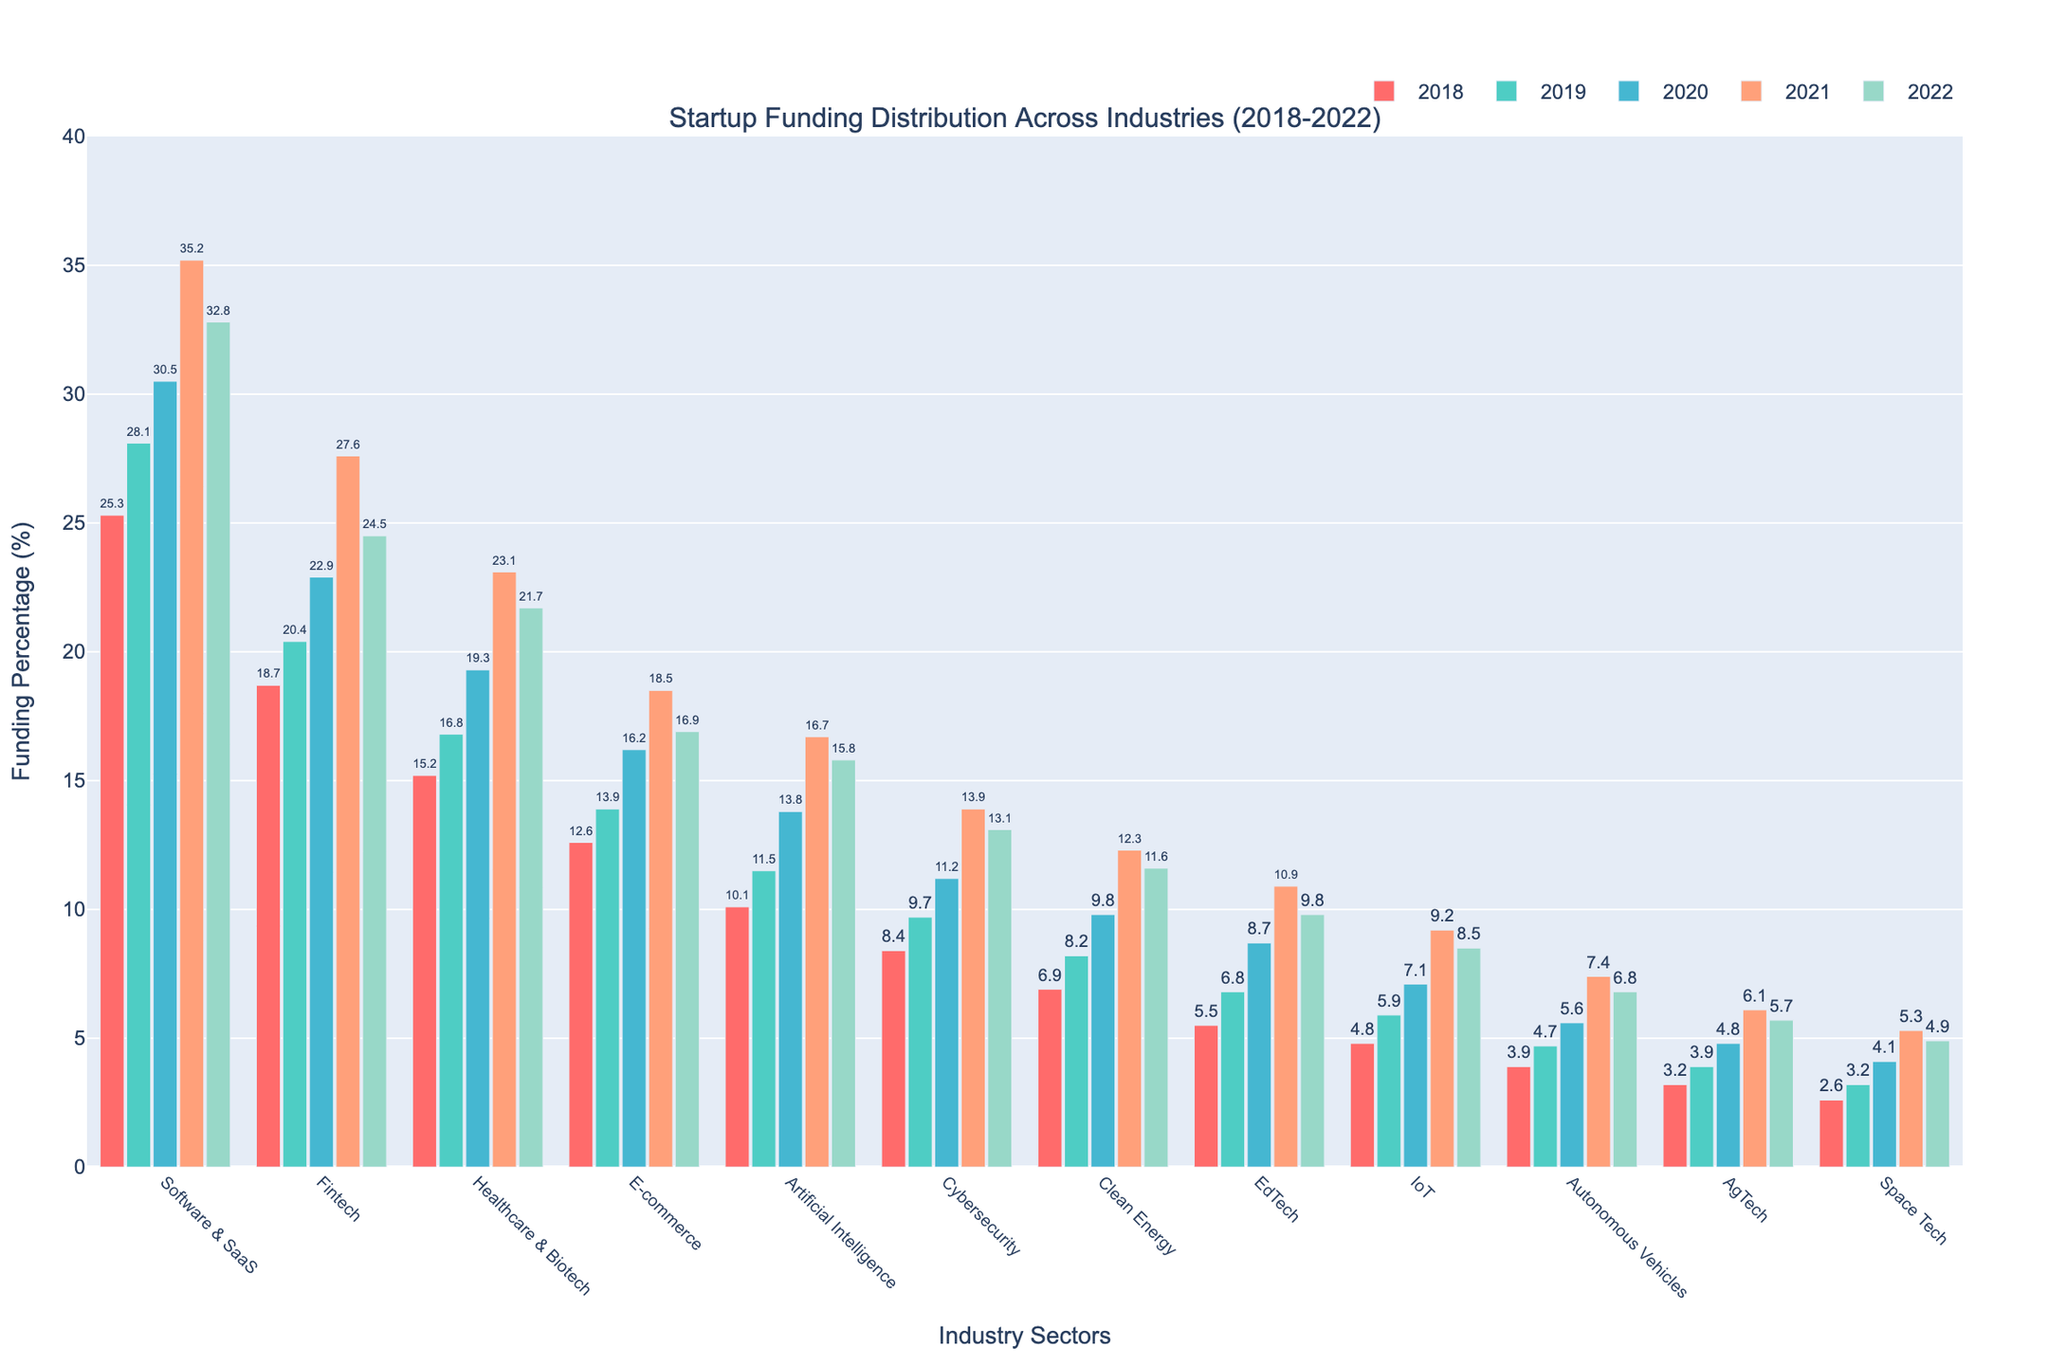What industry sector saw the highest percentage of startup funding in 2021? The bar for Software & SaaS in 2021 reaches the highest point among all sectors, indicating the highest percentage of funding.
Answer: Software & SaaS Which industry sector experienced the greatest increase in funding percentage from 2018 to 2022? By comparing the bars for each sector from 2018 to 2022, the Software & SaaS sector had an increase from 25.3% to 32.8%, an increase of 7.5 percentage points.
Answer: Software & SaaS Compare the funding percentages for the Fintech and Healthcare & Biotech sectors in 2020. Which sector received more funding? In 2020, the bar for Fintech is higher than Healthcare & Biotech, implying that Fintech received more funding.
Answer: Fintech What is the total funding percentage for the top three sectors in 2022? The top three sectors in 2022 by funding percentage are Software & SaaS (32.8%), Fintech (24.5%), and Healthcare & Biotech (21.7%). Summing these gives 32.8 + 24.5 + 21.7 = 79.0%.
Answer: 79.0% Which sector had a consistent increase in funding percentage every year from 2018 to 2021 but saw a decrease in 2022? By observing the trends, the Software & SaaS sector increased each year until 2021 where it peaked at 35.2% before dropping to 32.8% in 2022.
Answer: Software & SaaS Which sector had a funding percentage above 10% only starting in 2019? The EdTech sector had funding percentages of 5.5% in 2018 and increased to 6.8% in 2019, surpassing 10% in subsequent years.
Answer: EdTech What is the average funding percentage for the Clean Energy sector over the five years? Adding the Clean Energy percentages from 2018 to 2022 and dividing by 5, we get (6.9 + 8.2 + 9.8 + 12.3 + 11.6) / 5 = 48.8 / 5 = 9.76%.
Answer: 9.76% Which sector showed the smallest increase in funding percentage from 2018 to 2022? Checking the increase from 2018 to 2022 for all sectors, AgTech increased from 3.2% to 5.7%, which is the smallest increase of 2.5 percentage points.
Answer: AgTech How did the percentage of funding for Autonomous Vehicles change from 2018 to 2021? The funding percentage for Autonomous Vehicles increased from 3.9% in 2018 to 7.4% in 2021. This is an increase of 3.5 percentage points.
Answer: Increased Identify the sectors that had a funding percentage below 5% in any given year. The sectors that had below 5% funding in some years are AgTech, Space Tech, and Autonomous Vehicles.
Answer: AgTech, Space Tech, Autonomous Vehicles 